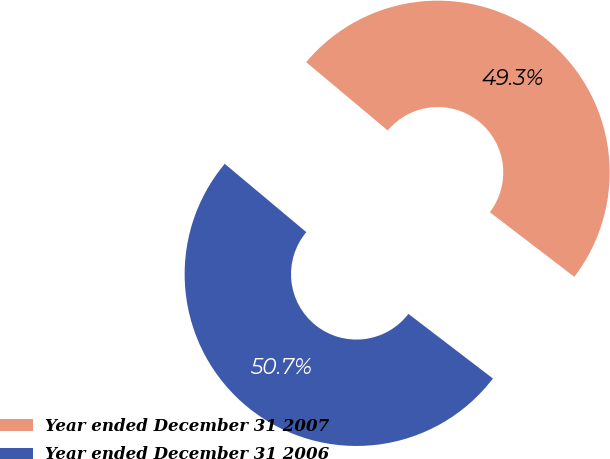Convert chart to OTSL. <chart><loc_0><loc_0><loc_500><loc_500><pie_chart><fcel>Year ended December 31 2007<fcel>Year ended December 31 2006<nl><fcel>49.29%<fcel>50.71%<nl></chart> 